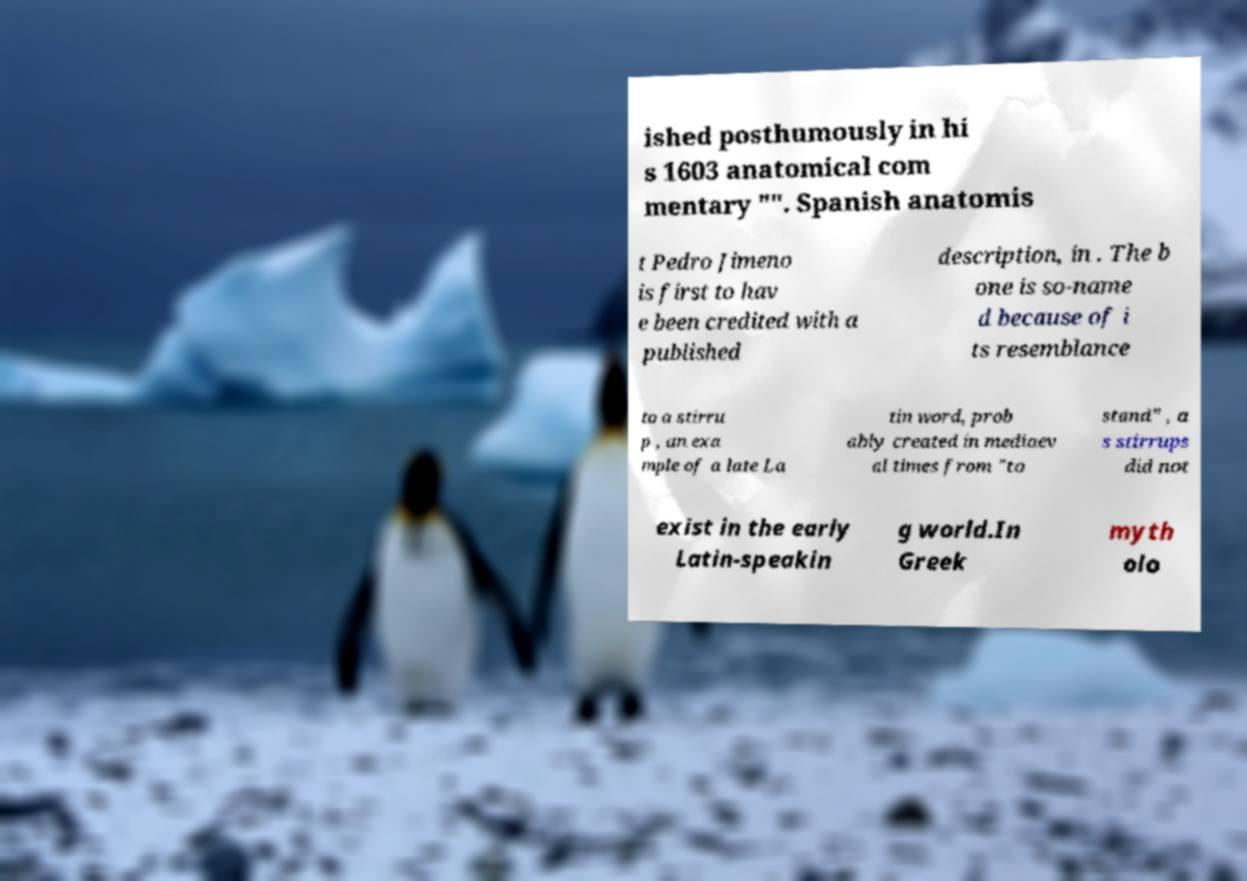Can you accurately transcribe the text from the provided image for me? ished posthumously in hi s 1603 anatomical com mentary "". Spanish anatomis t Pedro Jimeno is first to hav e been credited with a published description, in . The b one is so-name d because of i ts resemblance to a stirru p , an exa mple of a late La tin word, prob ably created in mediaev al times from "to stand" , a s stirrups did not exist in the early Latin-speakin g world.In Greek myth olo 